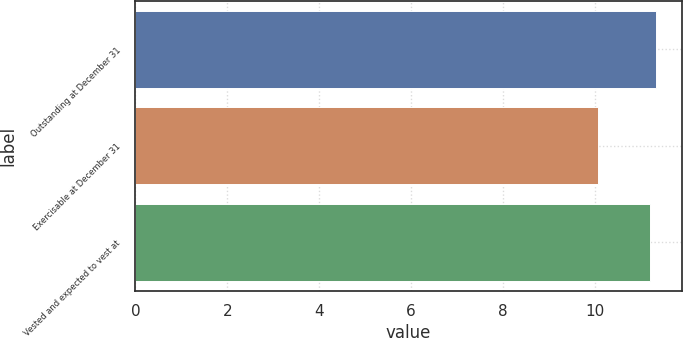Convert chart to OTSL. <chart><loc_0><loc_0><loc_500><loc_500><bar_chart><fcel>Outstanding at December 31<fcel>Exercisable at December 31<fcel>Vested and expected to vest at<nl><fcel>11.33<fcel>10.07<fcel>11.21<nl></chart> 